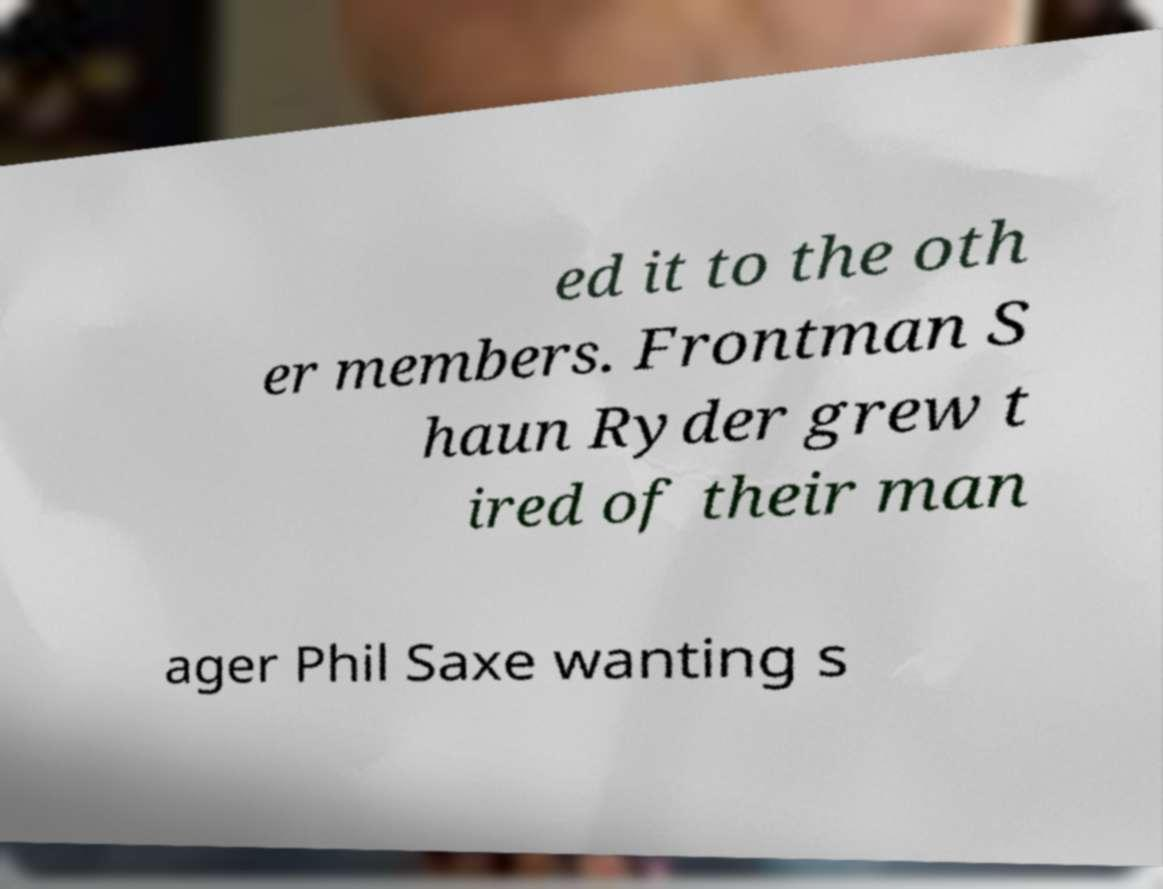There's text embedded in this image that I need extracted. Can you transcribe it verbatim? ed it to the oth er members. Frontman S haun Ryder grew t ired of their man ager Phil Saxe wanting s 